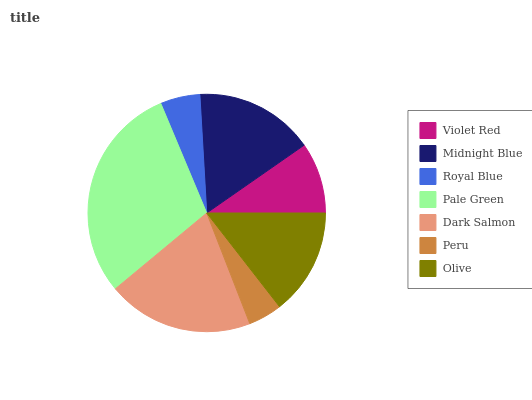Is Peru the minimum?
Answer yes or no. Yes. Is Pale Green the maximum?
Answer yes or no. Yes. Is Midnight Blue the minimum?
Answer yes or no. No. Is Midnight Blue the maximum?
Answer yes or no. No. Is Midnight Blue greater than Violet Red?
Answer yes or no. Yes. Is Violet Red less than Midnight Blue?
Answer yes or no. Yes. Is Violet Red greater than Midnight Blue?
Answer yes or no. No. Is Midnight Blue less than Violet Red?
Answer yes or no. No. Is Olive the high median?
Answer yes or no. Yes. Is Olive the low median?
Answer yes or no. Yes. Is Dark Salmon the high median?
Answer yes or no. No. Is Violet Red the low median?
Answer yes or no. No. 